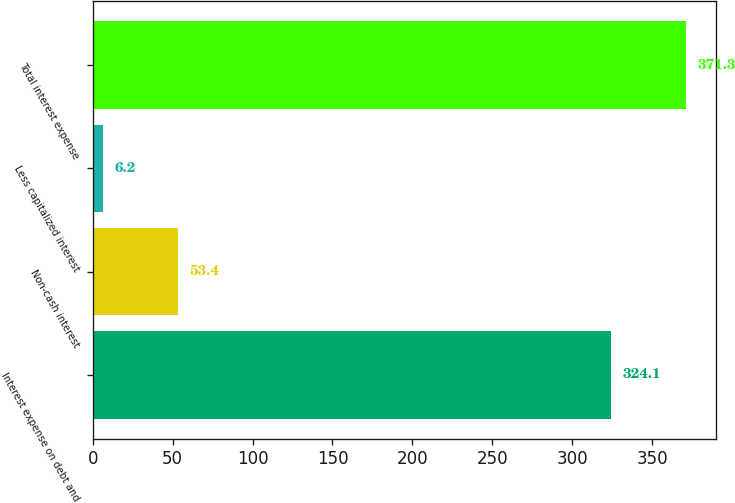<chart> <loc_0><loc_0><loc_500><loc_500><bar_chart><fcel>Interest expense on debt and<fcel>Non-cash interest<fcel>Less capitalized interest<fcel>Total interest expense<nl><fcel>324.1<fcel>53.4<fcel>6.2<fcel>371.3<nl></chart> 